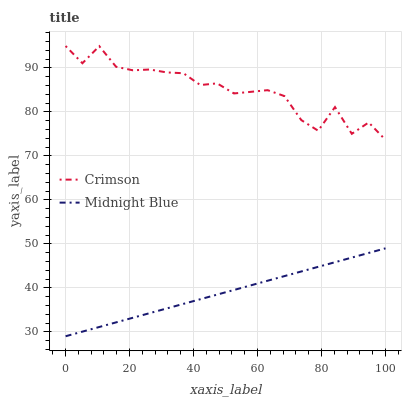Does Midnight Blue have the minimum area under the curve?
Answer yes or no. Yes. Does Crimson have the maximum area under the curve?
Answer yes or no. Yes. Does Midnight Blue have the maximum area under the curve?
Answer yes or no. No. Is Midnight Blue the smoothest?
Answer yes or no. Yes. Is Crimson the roughest?
Answer yes or no. Yes. Is Midnight Blue the roughest?
Answer yes or no. No. Does Midnight Blue have the lowest value?
Answer yes or no. Yes. Does Crimson have the highest value?
Answer yes or no. Yes. Does Midnight Blue have the highest value?
Answer yes or no. No. Is Midnight Blue less than Crimson?
Answer yes or no. Yes. Is Crimson greater than Midnight Blue?
Answer yes or no. Yes. Does Midnight Blue intersect Crimson?
Answer yes or no. No. 